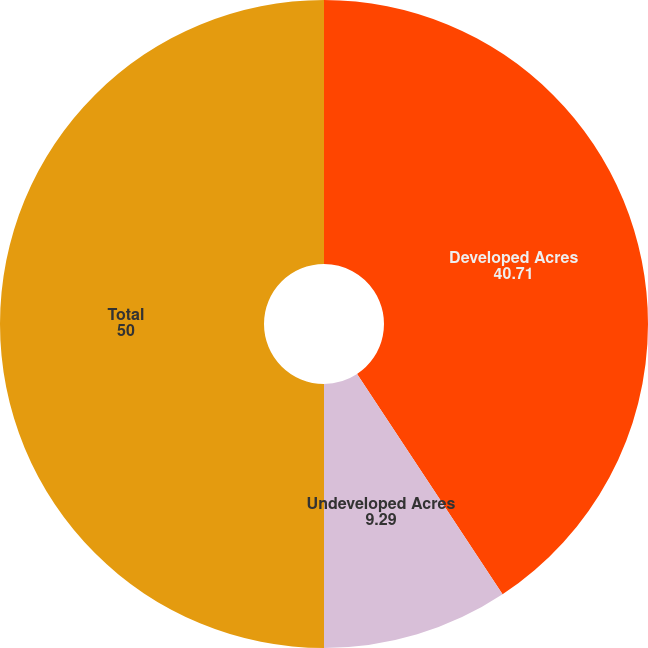<chart> <loc_0><loc_0><loc_500><loc_500><pie_chart><fcel>Developed Acres<fcel>Undeveloped Acres<fcel>Total<nl><fcel>40.71%<fcel>9.29%<fcel>50.0%<nl></chart> 